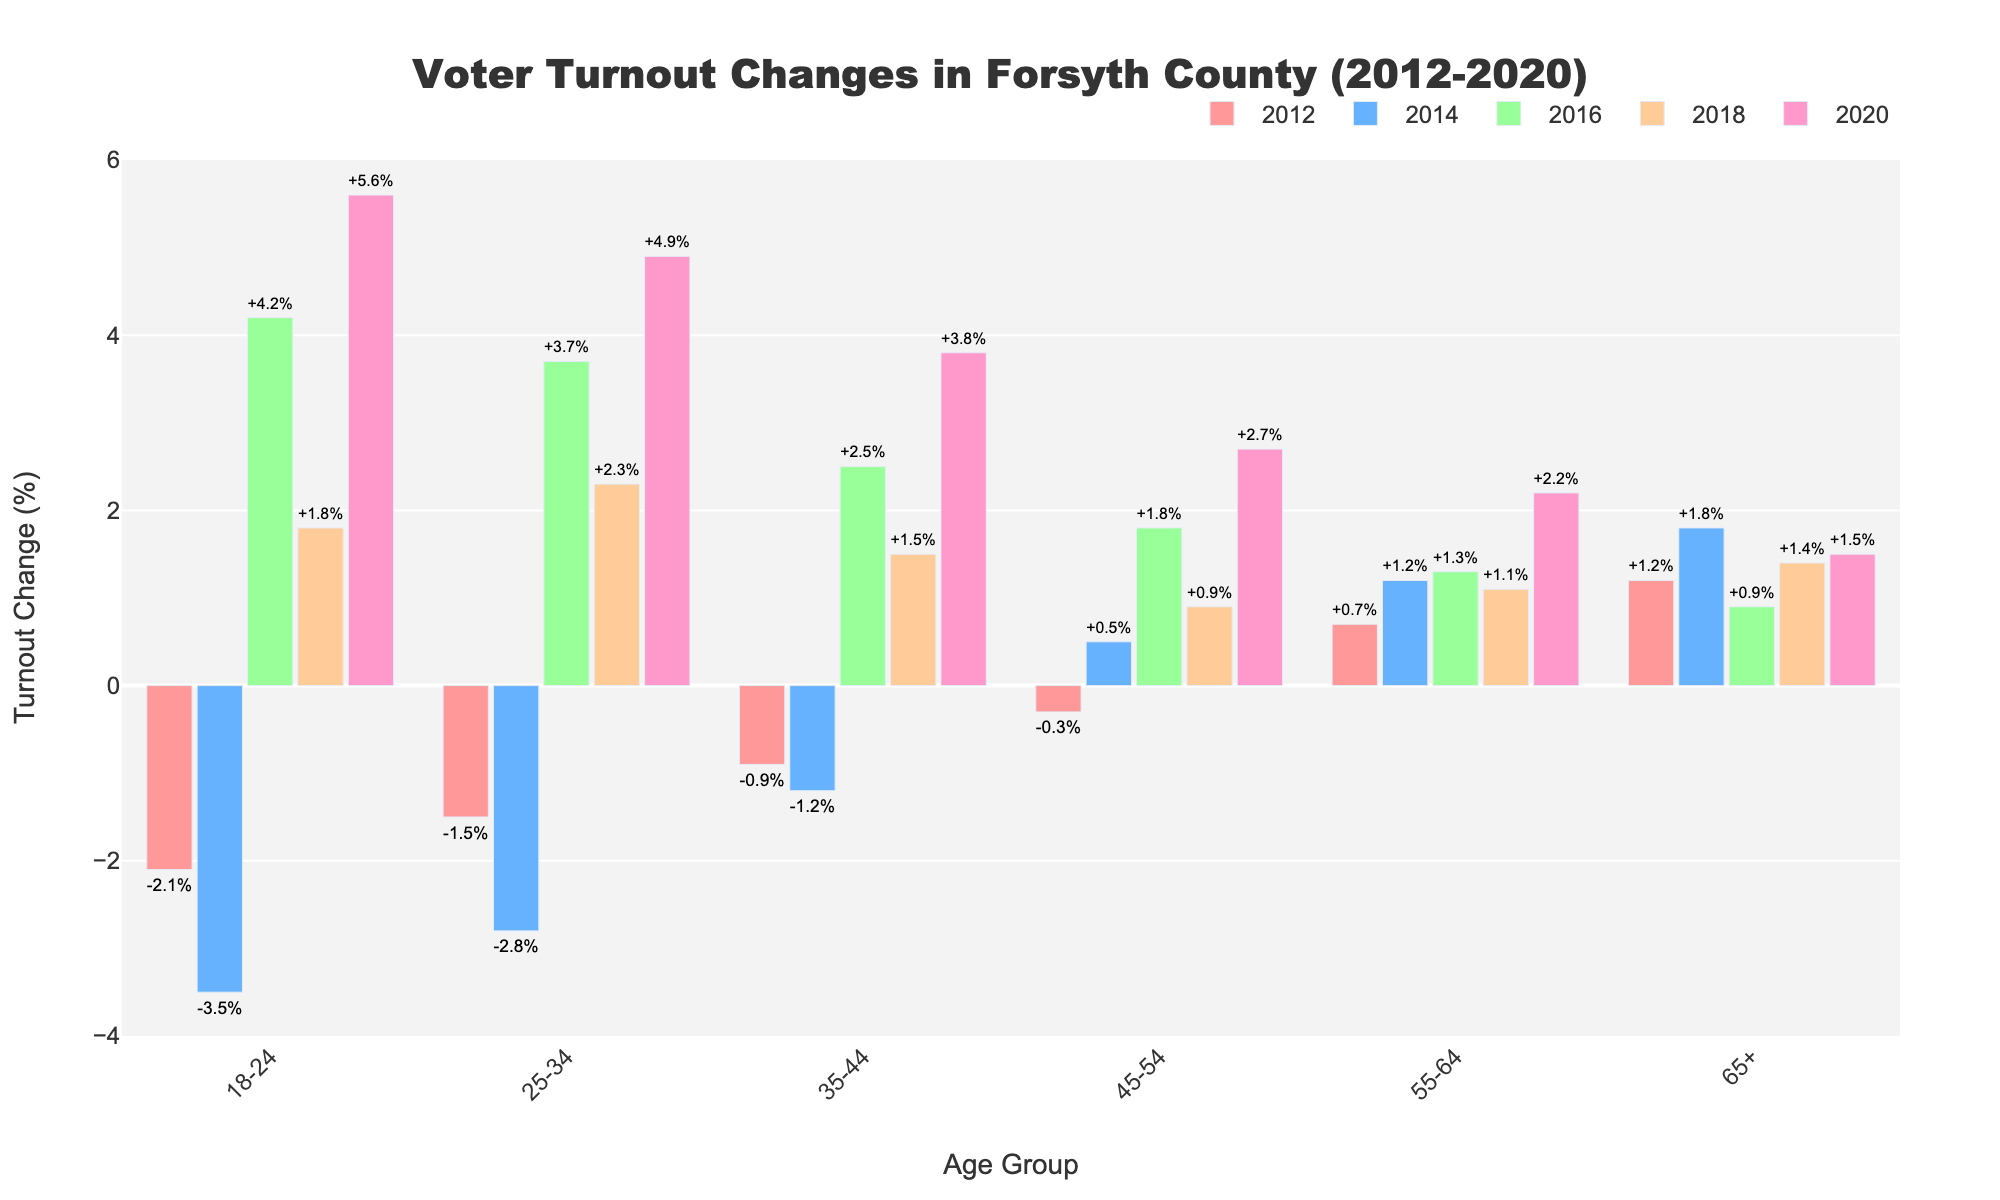What's the title of the chart? The title is displayed at the top of the chart, and it reads "Voter Turnout Changes in Forsyth County (2012-2020)"
Answer: Voter Turnout Changes in Forsyth County (2012-2020) How do the voter turnout changes for the age group 18-24 compare in 2012 and 2020? Look at the bars for the 18-24 age group for the years 2012 and 2020. In 2012, it shows -2.1%, while in 2020, it shows 5.6%.
Answer: 2012: -2.1%, 2020: 5.6% Which age group shows a consistent increase in voter turnout changes over time? Examine the trend for each age group across all years. The 65+ age group shows a consistent increase each year.
Answer: 65+ For the 25-34 age group, what is the difference in voter turnout changes between 2012 and 2014? Subtract the 2012 voter turnout change for the 25-34 age group (-1.5%) from the 2014 voter turnout change (-2.8%). The calculation is -2.8% - (-1.5%) = -1.3%.
Answer: -1.3% Which year had the highest voter turnout change for the 45-54 age group? Look for the maximum bar in the 45-54 age group across all years. The highest value is 2.7% in 2020.
Answer: 2020 In which year did the 55-64 age group see its smallest positive change in voter turnout? Compare the bars for the 55-64 age group across all years and find the smallest positive value, which is in 2016 at 1.3%.
Answer: 2016 How has the voter turnout for the 18-24 age group changed from 2018 to 2020? Subtract the 2018 voter turnout change (1.8%) for the 18-24 age group from the 2020 turnout change (5.6%). The calculation is 5.6% - 1.8% = 3.8%.
Answer: 3.8% What's the overall trend in voter turnout changes for the 35-44 age group from 2012 to 2020? Examine the trend of the voter turnout percentage for the 35-44 age group from 2012 (-0.9%) to 2020 (3.8%). The overall trend is an increase.
Answer: Increase Which two age groups had negative voter turnout changes in 2012? Look at the bars for 2012 and identify the age groups with negative values, which are 18-24 and 25-34.
Answer: 18-24 and 25-34 By how much did the voter turnout change increase for the 45-54 age group from 2014 to 2016? Subtract the 2014 voter turnout change (0.5%) from the 2016 turnout change (1.8%) for the 45-54 age group. The calculation is 1.8% - 0.5% = 1.3%.
Answer: 1.3% 